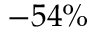Convert formula to latex. <formula><loc_0><loc_0><loc_500><loc_500>- 5 4 \%</formula> 